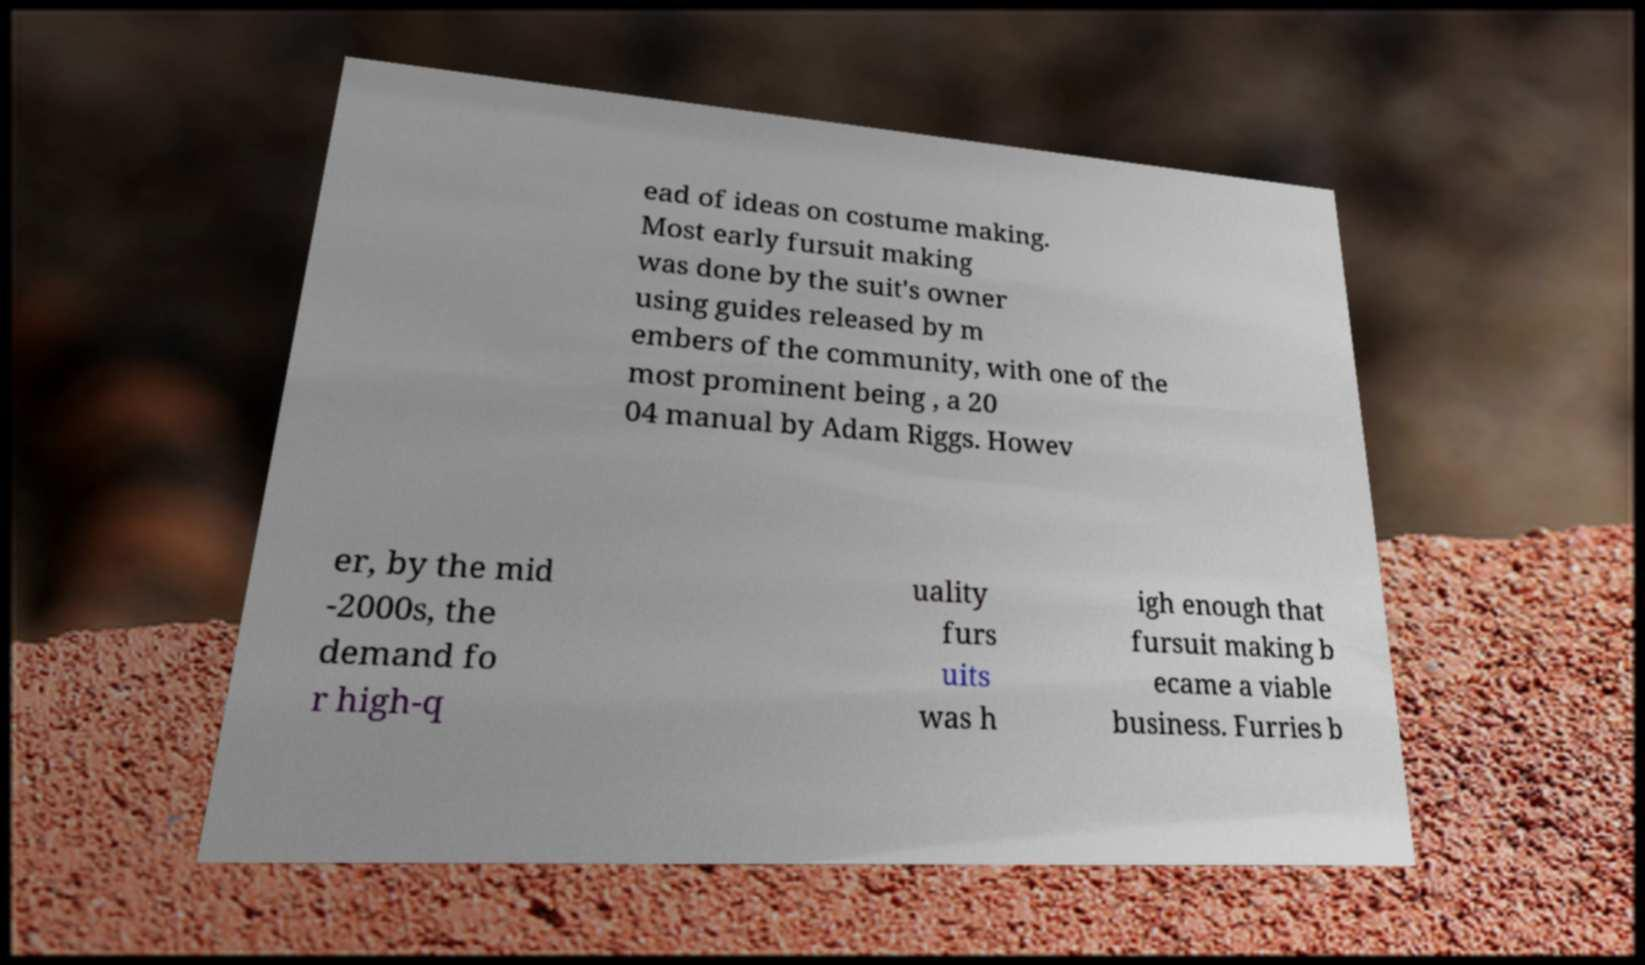Please read and relay the text visible in this image. What does it say? ead of ideas on costume making. Most early fursuit making was done by the suit's owner using guides released by m embers of the community, with one of the most prominent being , a 20 04 manual by Adam Riggs. Howev er, by the mid -2000s, the demand fo r high-q uality furs uits was h igh enough that fursuit making b ecame a viable business. Furries b 